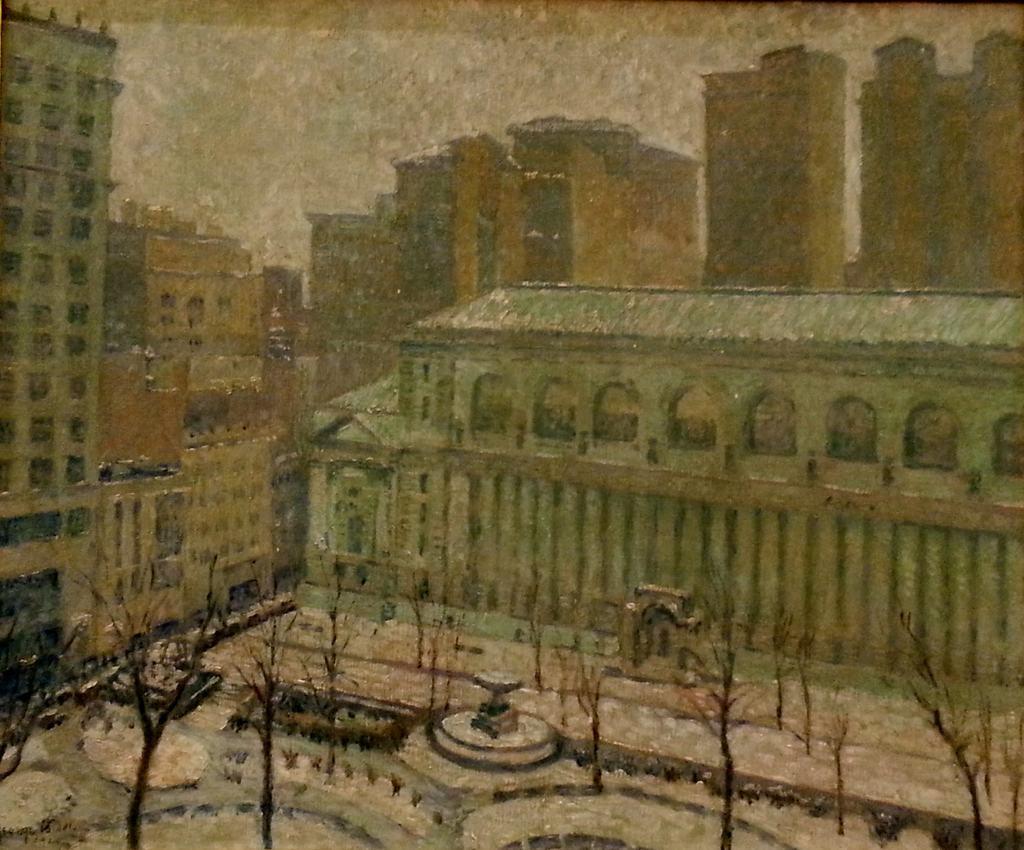In one or two sentences, can you explain what this image depicts? In this image we can see a painting. In the painting we can see a group of buildings. At the top we can see the sky. In front of the buildings we can see the trees. 